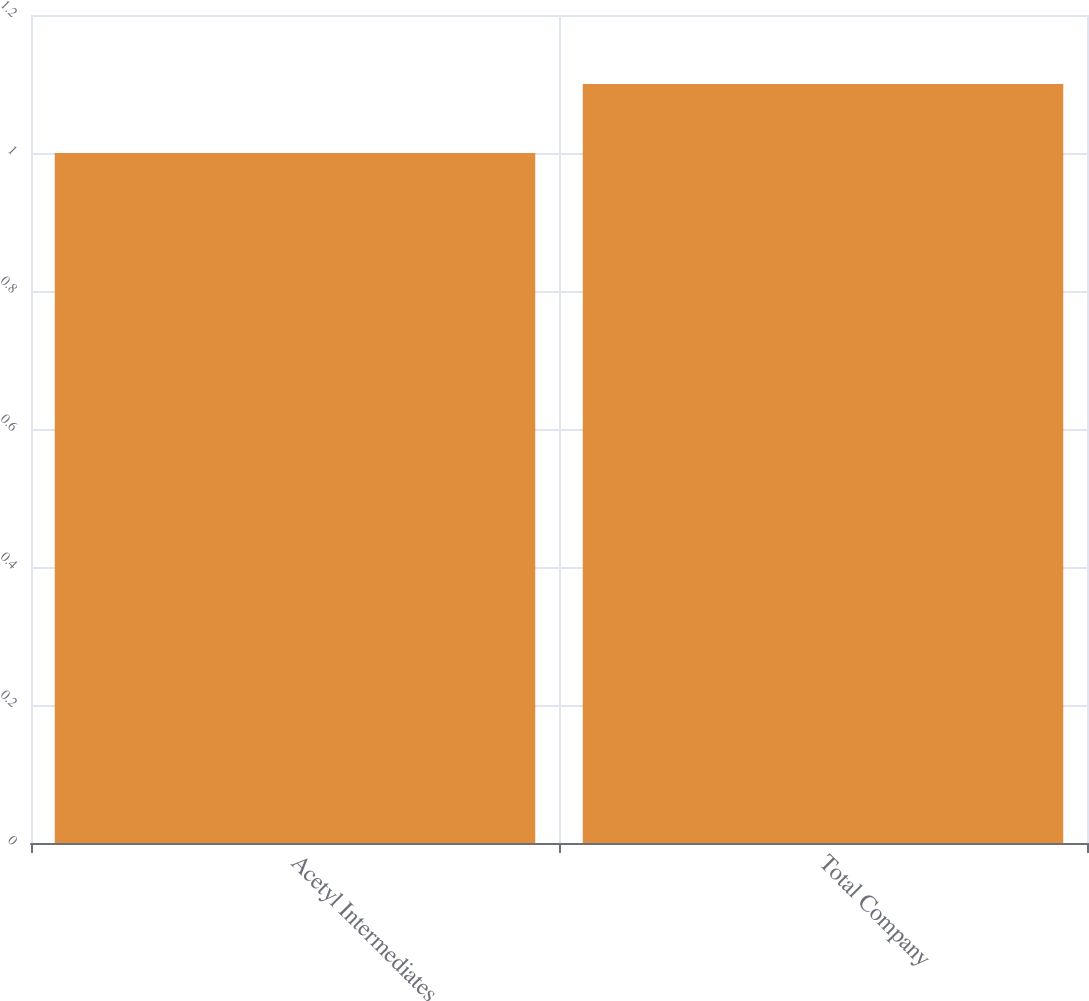Convert chart. <chart><loc_0><loc_0><loc_500><loc_500><bar_chart><fcel>Acetyl Intermediates<fcel>Total Company<nl><fcel>1<fcel>1.1<nl></chart> 